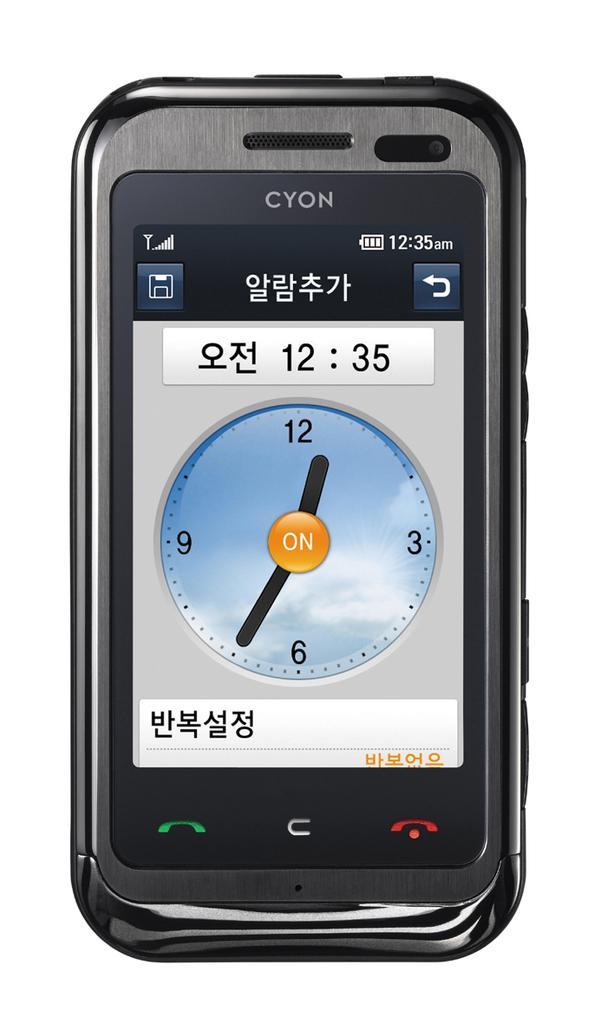<image>
Describe the image concisely. A clock app on a CYON phone indicated the time is 12:35. 